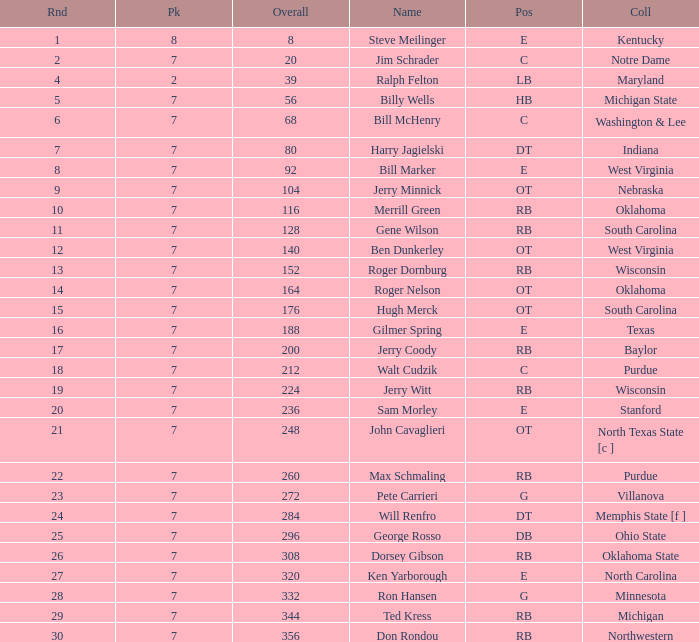I'm looking to parse the entire table for insights. Could you assist me with that? {'header': ['Rnd', 'Pk', 'Overall', 'Name', 'Pos', 'Coll'], 'rows': [['1', '8', '8', 'Steve Meilinger', 'E', 'Kentucky'], ['2', '7', '20', 'Jim Schrader', 'C', 'Notre Dame'], ['4', '2', '39', 'Ralph Felton', 'LB', 'Maryland'], ['5', '7', '56', 'Billy Wells', 'HB', 'Michigan State'], ['6', '7', '68', 'Bill McHenry', 'C', 'Washington & Lee'], ['7', '7', '80', 'Harry Jagielski', 'DT', 'Indiana'], ['8', '7', '92', 'Bill Marker', 'E', 'West Virginia'], ['9', '7', '104', 'Jerry Minnick', 'OT', 'Nebraska'], ['10', '7', '116', 'Merrill Green', 'RB', 'Oklahoma'], ['11', '7', '128', 'Gene Wilson', 'RB', 'South Carolina'], ['12', '7', '140', 'Ben Dunkerley', 'OT', 'West Virginia'], ['13', '7', '152', 'Roger Dornburg', 'RB', 'Wisconsin'], ['14', '7', '164', 'Roger Nelson', 'OT', 'Oklahoma'], ['15', '7', '176', 'Hugh Merck', 'OT', 'South Carolina'], ['16', '7', '188', 'Gilmer Spring', 'E', 'Texas'], ['17', '7', '200', 'Jerry Coody', 'RB', 'Baylor'], ['18', '7', '212', 'Walt Cudzik', 'C', 'Purdue'], ['19', '7', '224', 'Jerry Witt', 'RB', 'Wisconsin'], ['20', '7', '236', 'Sam Morley', 'E', 'Stanford'], ['21', '7', '248', 'John Cavaglieri', 'OT', 'North Texas State [c ]'], ['22', '7', '260', 'Max Schmaling', 'RB', 'Purdue'], ['23', '7', '272', 'Pete Carrieri', 'G', 'Villanova'], ['24', '7', '284', 'Will Renfro', 'DT', 'Memphis State [f ]'], ['25', '7', '296', 'George Rosso', 'DB', 'Ohio State'], ['26', '7', '308', 'Dorsey Gibson', 'RB', 'Oklahoma State'], ['27', '7', '320', 'Ken Yarborough', 'E', 'North Carolina'], ['28', '7', '332', 'Ron Hansen', 'G', 'Minnesota'], ['29', '7', '344', 'Ted Kress', 'RB', 'Michigan'], ['30', '7', '356', 'Don Rondou', 'RB', 'Northwestern']]} What is the number of the round in which Ron Hansen was drafted and the overall is greater than 332? 0.0. 